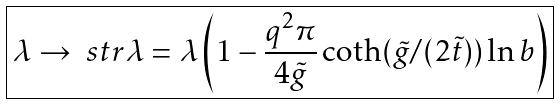<formula> <loc_0><loc_0><loc_500><loc_500>\boxed { \lambda \rightarrow \ s t r { \lambda } = \lambda \left ( 1 - \frac { q ^ { 2 } \pi } { 4 \tilde { g } } \coth ( \tilde { g } / ( 2 \tilde { t } ) ) \ln b \right ) }</formula> 